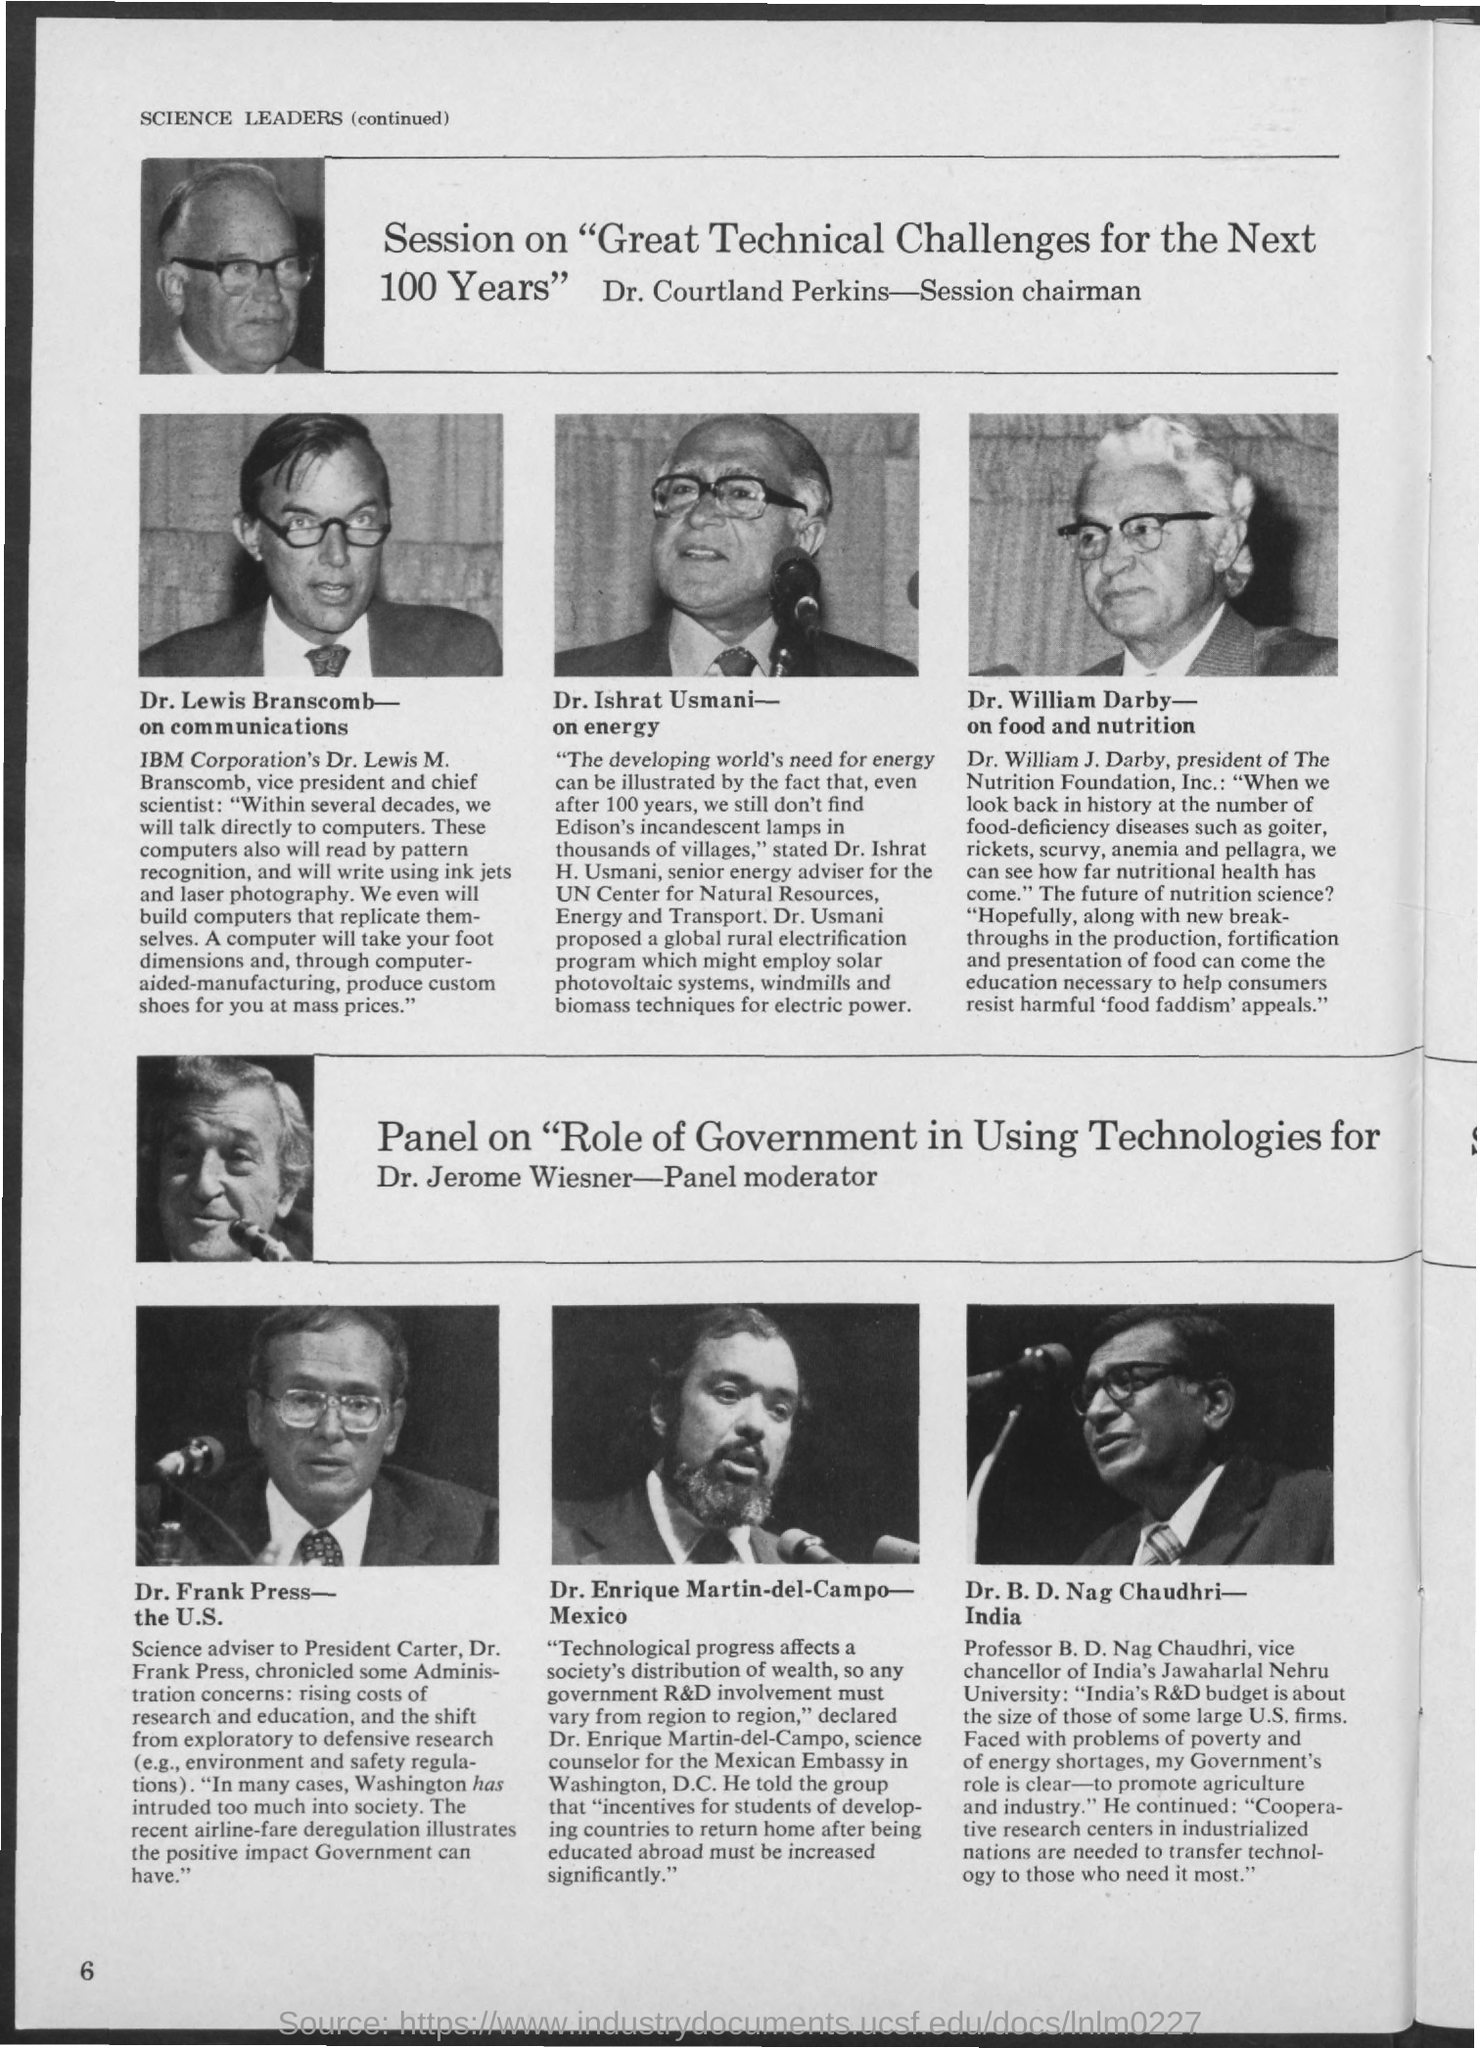Who is the Session Chairman?
Your answer should be compact. Dr. courtland perkins. Who is the Panel Moderator?
Provide a succinct answer. Dr. jerome wiesner. 